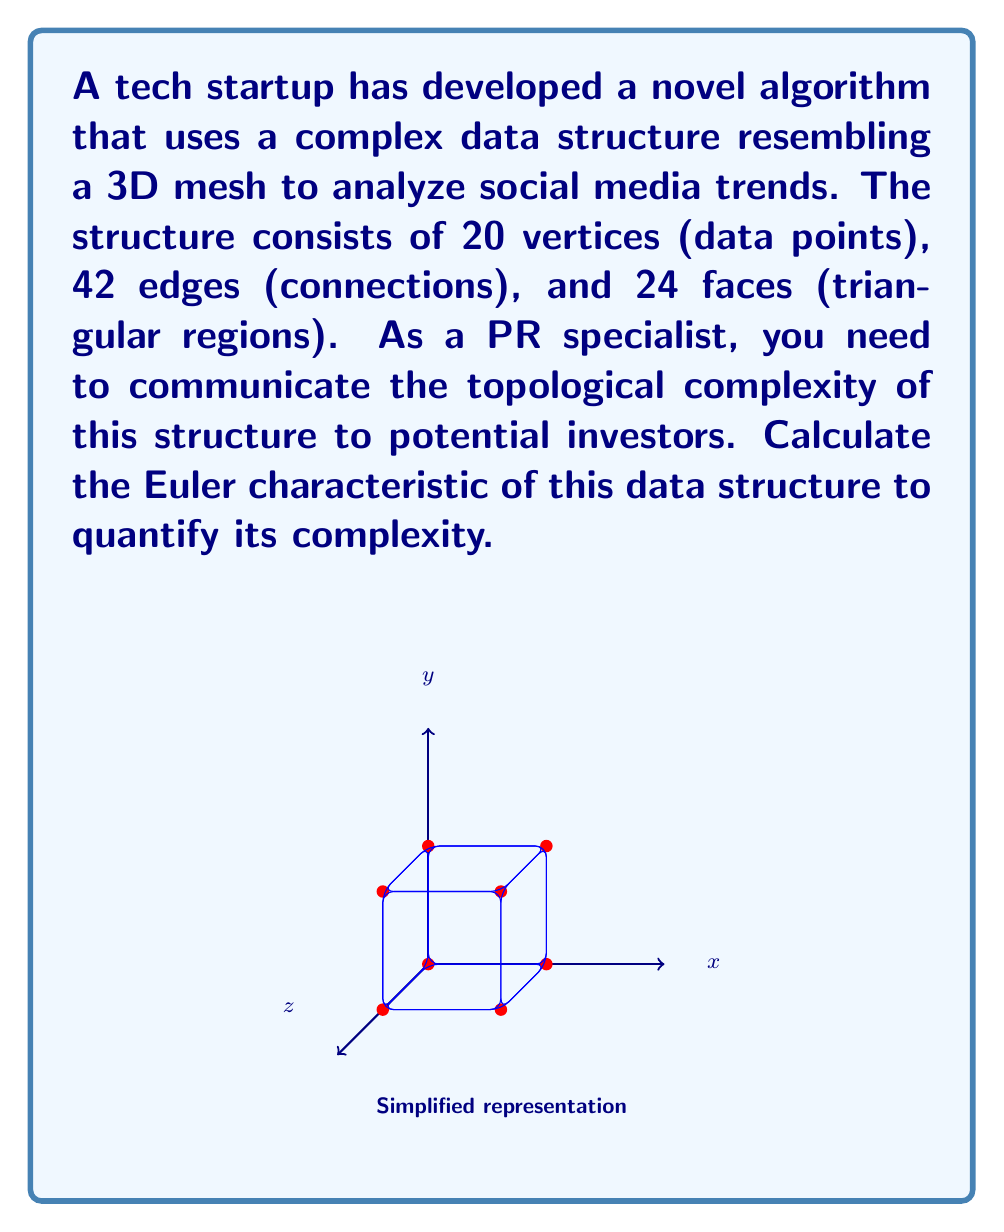Provide a solution to this math problem. To calculate the Euler characteristic of the data structure, we'll use the formula:

$$\chi = V - E + F$$

Where:
$\chi$ (chi) is the Euler characteristic
$V$ is the number of vertices
$E$ is the number of edges
$F$ is the number of faces

Given:
$V = 20$ (vertices/data points)
$E = 42$ (edges/connections)
$F = 24$ (faces/triangular regions)

Let's substitute these values into the formula:

$$\chi = 20 - 42 + 24$$

Now, let's perform the calculation:

$$\chi = 20 - 42 + 24 = 2$$

The Euler characteristic of this data structure is 2, which is interesting because it's the same as for a sphere or any convex polyhedron. This suggests that despite its complexity, the structure has some fundamental similarities to simpler 3D objects.

In the context of PR for the startup, you can explain that the Euler characteristic provides a single number that encapsulates the topological complexity of the data structure. A positive Euler characteristic (like 2) indicates a certain level of "connectedness" and "closure" in the structure, which could be presented as a strength of the algorithm in capturing comprehensive relationships in social media trends.
Answer: $\chi = 2$ 